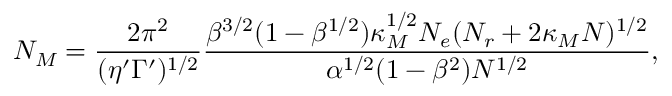Convert formula to latex. <formula><loc_0><loc_0><loc_500><loc_500>N _ { M } = \frac { 2 \pi ^ { 2 } } { ( \eta ^ { \prime } \Gamma ^ { \prime } ) ^ { 1 / 2 } } \frac { \beta ^ { 3 / 2 } ( 1 - \beta ^ { 1 / 2 } ) \kappa _ { M } ^ { 1 / 2 } N _ { e } ( N _ { r } + 2 \kappa _ { M } N ) ^ { 1 / 2 } } { \alpha ^ { 1 / 2 } ( 1 - \beta ^ { 2 } ) N ^ { 1 / 2 } } ,</formula> 